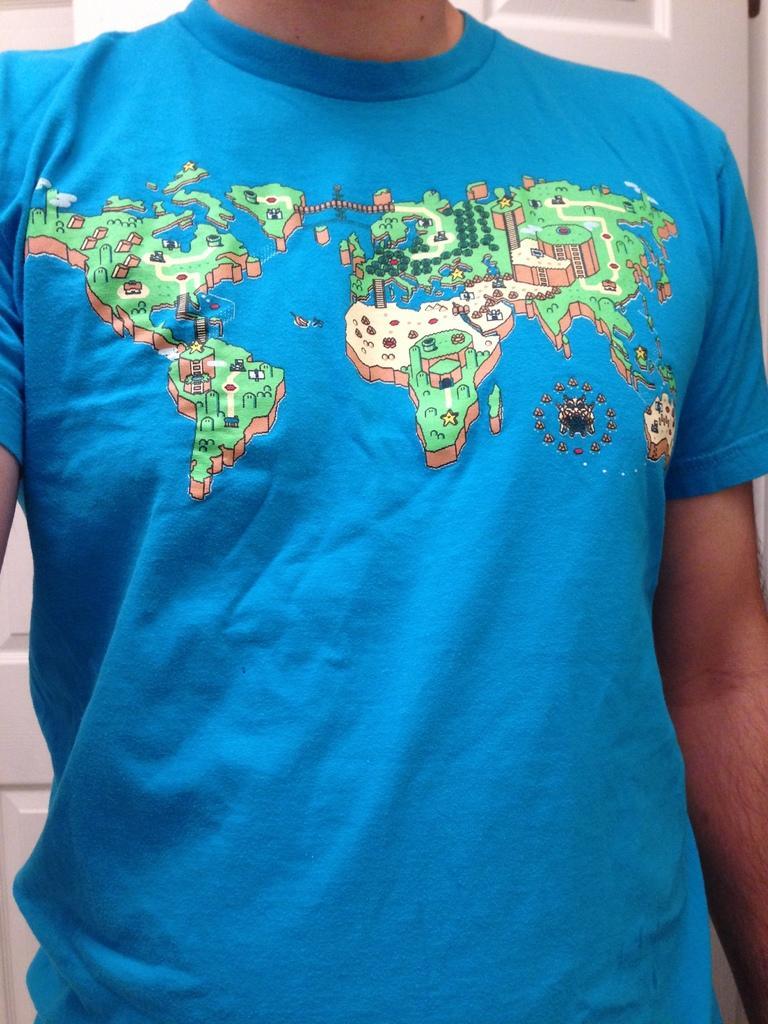Could you give a brief overview of what you see in this image? In this image we can see there is a person wearing blue t-shirt where we can see there is a map on it. 